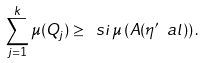Convert formula to latex. <formula><loc_0><loc_0><loc_500><loc_500>\sum _ { j = 1 } ^ { k } \mu ( Q _ { j } ) \geq \ s i \, \mu \left ( A ( \eta ^ { \prime } \ a l ) \right ) .</formula> 